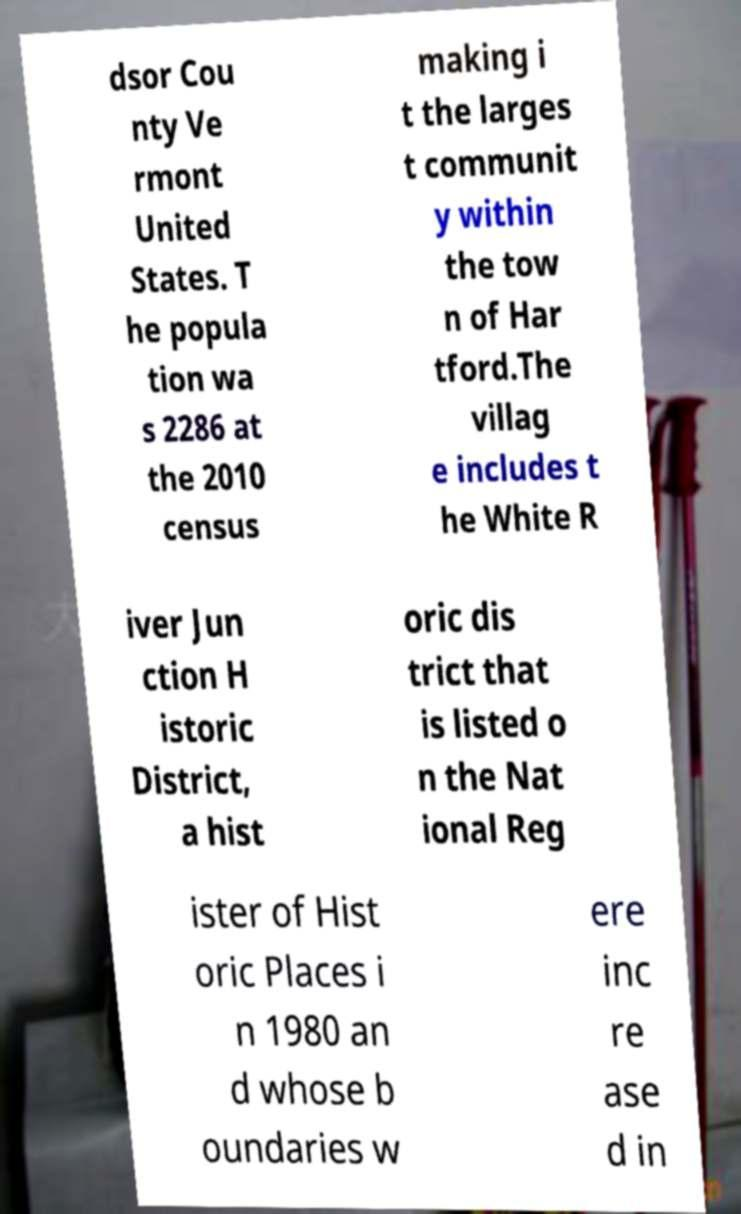Can you read and provide the text displayed in the image?This photo seems to have some interesting text. Can you extract and type it out for me? dsor Cou nty Ve rmont United States. T he popula tion wa s 2286 at the 2010 census making i t the larges t communit y within the tow n of Har tford.The villag e includes t he White R iver Jun ction H istoric District, a hist oric dis trict that is listed o n the Nat ional Reg ister of Hist oric Places i n 1980 an d whose b oundaries w ere inc re ase d in 